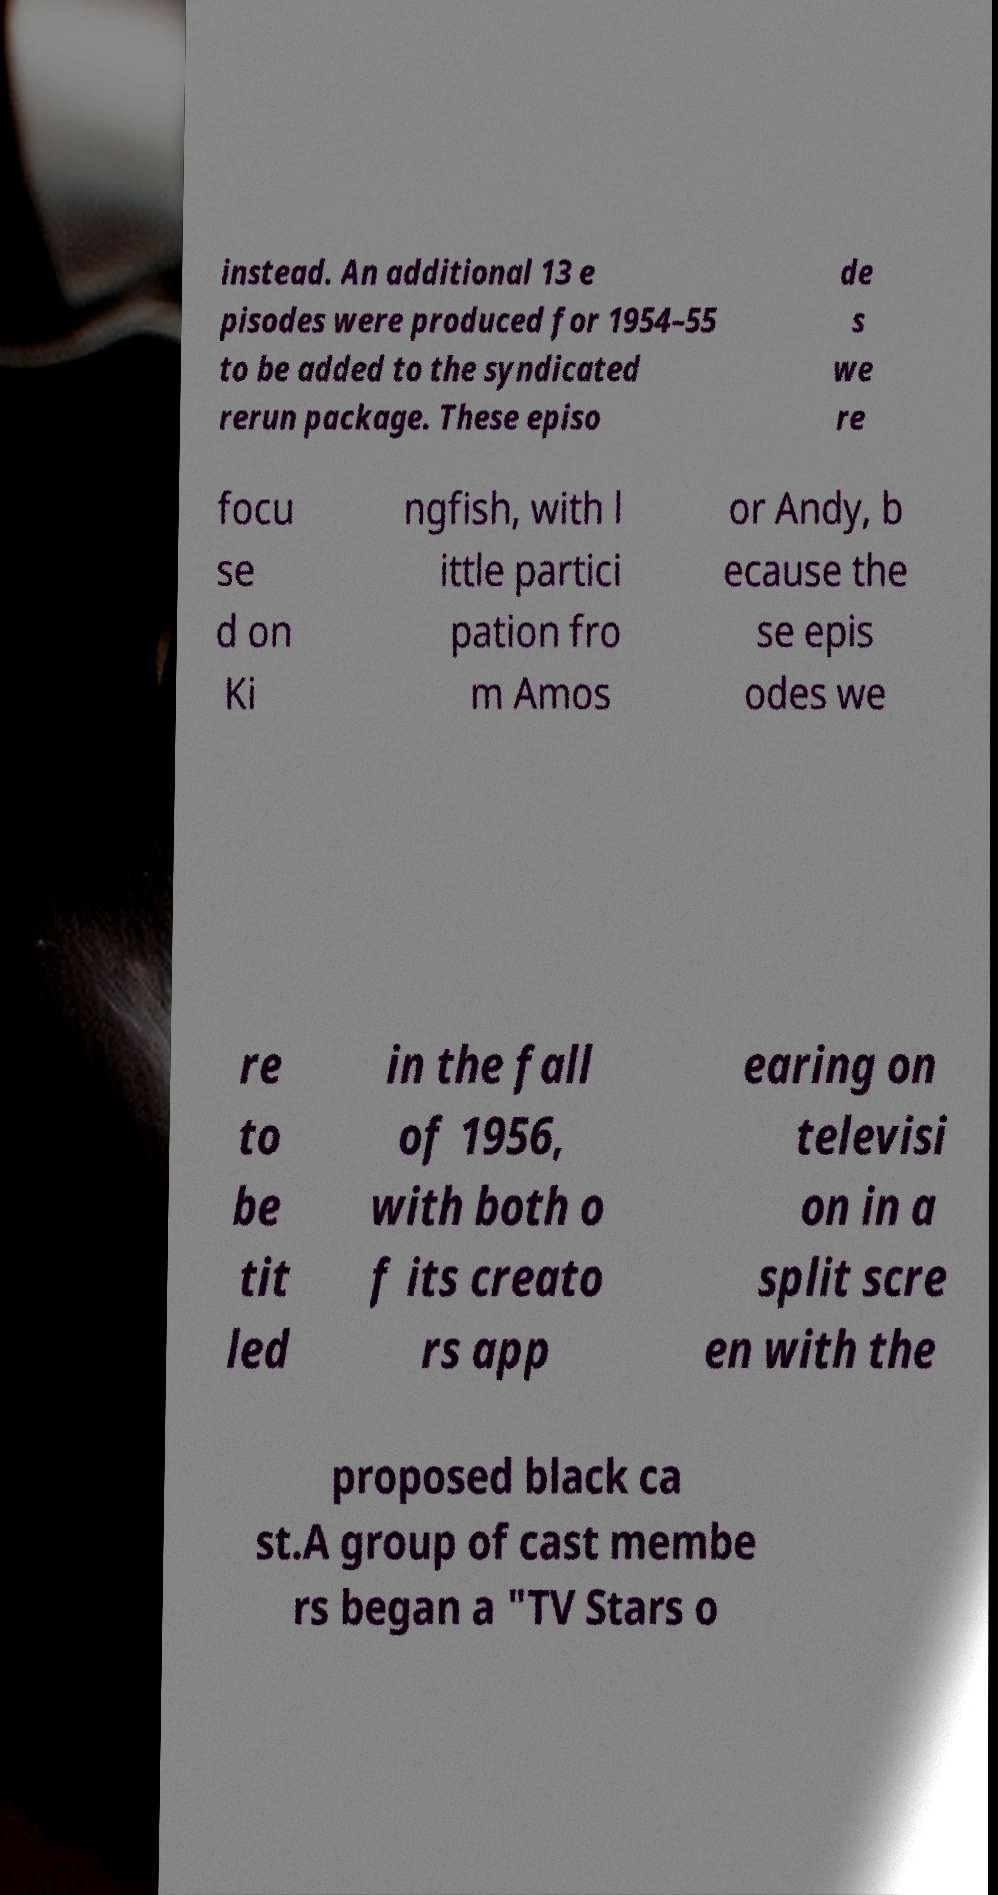There's text embedded in this image that I need extracted. Can you transcribe it verbatim? instead. An additional 13 e pisodes were produced for 1954–55 to be added to the syndicated rerun package. These episo de s we re focu se d on Ki ngfish, with l ittle partici pation fro m Amos or Andy, b ecause the se epis odes we re to be tit led in the fall of 1956, with both o f its creato rs app earing on televisi on in a split scre en with the proposed black ca st.A group of cast membe rs began a "TV Stars o 